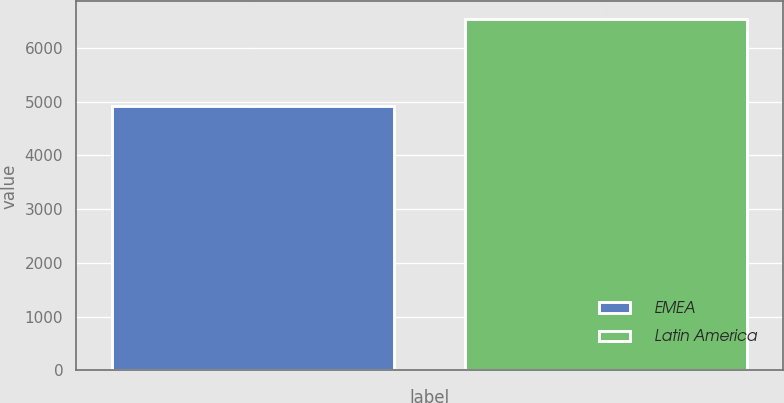<chart> <loc_0><loc_0><loc_500><loc_500><bar_chart><fcel>EMEA<fcel>Latin America<nl><fcel>4910<fcel>6535<nl></chart> 